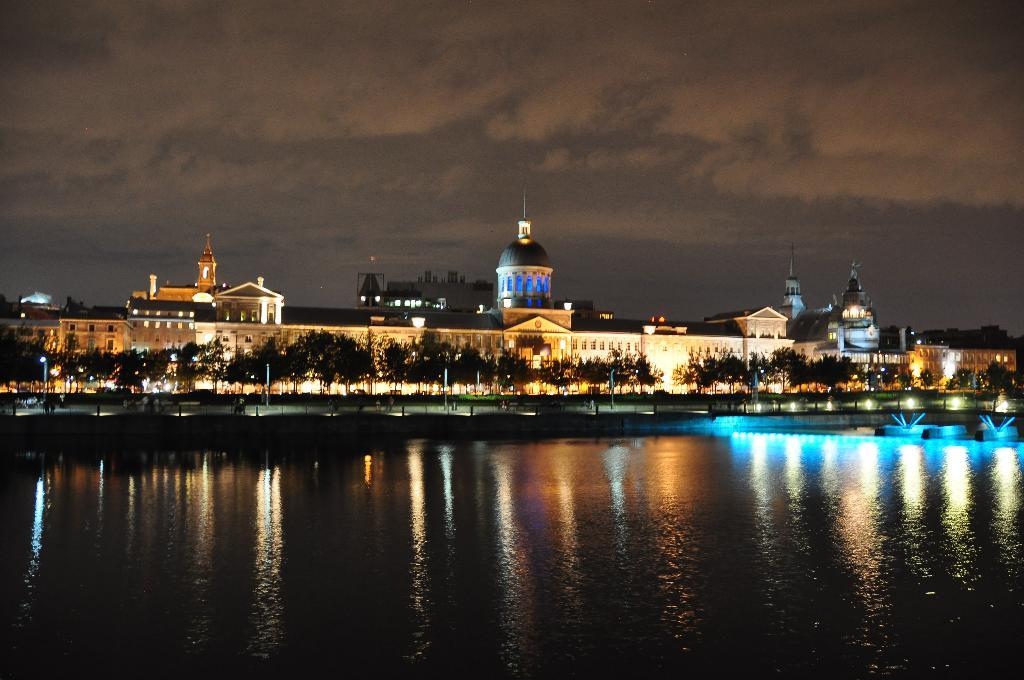What is the primary element visible in the image? There is water in the image. What type of natural vegetation can be seen in the image? There are trees in the image. What type of man-made structures are present in the image? There are buildings in the image. What part of the natural environment is visible in the image? The sky is visible in the image. What month is it in the image? The month cannot be determined from the image, as it does not contain any information about the time of year. 